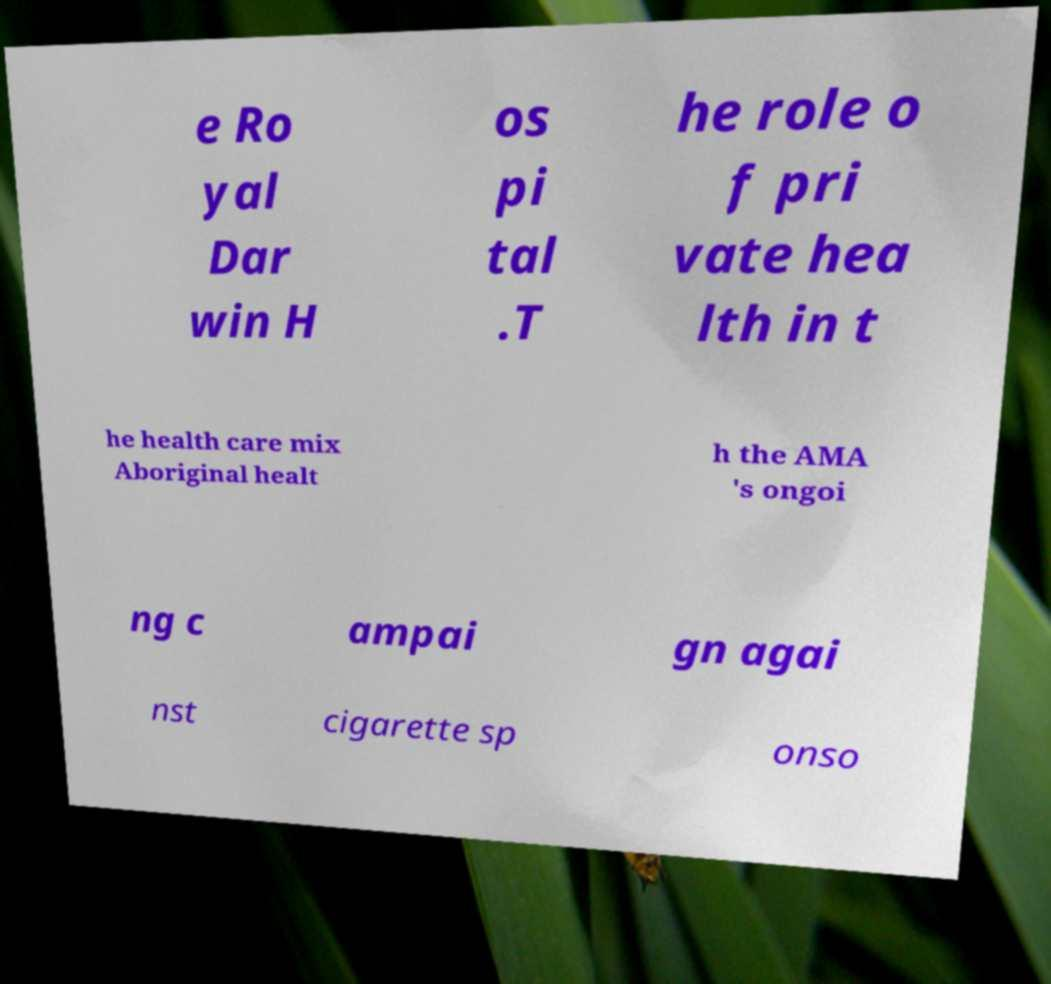Could you extract and type out the text from this image? e Ro yal Dar win H os pi tal .T he role o f pri vate hea lth in t he health care mix Aboriginal healt h the AMA 's ongoi ng c ampai gn agai nst cigarette sp onso 